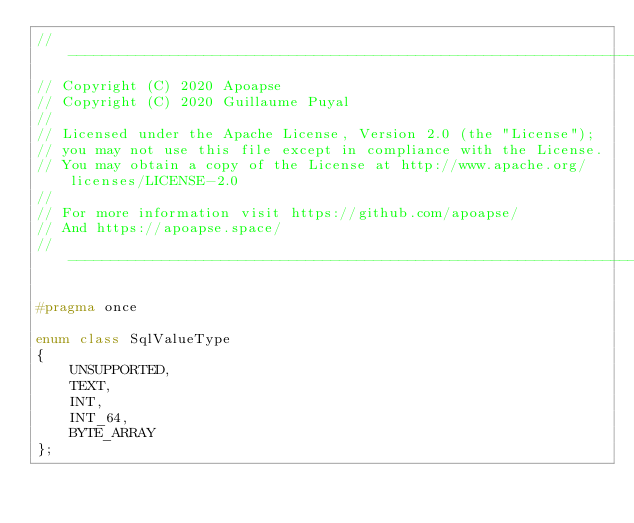<code> <loc_0><loc_0><loc_500><loc_500><_C++_>// ----------------------------------------------------------------------------
// Copyright (C) 2020 Apoapse
// Copyright (C) 2020 Guillaume Puyal
//
// Licensed under the Apache License, Version 2.0 (the "License");
// you may not use this file except in compliance with the License.
// You may obtain a copy of the License at http://www.apache.org/licenses/LICENSE-2.0
//
// For more information visit https://github.com/apoapse/
// And https://apoapse.space/
// ----------------------------------------------------------------------------

#pragma once

enum class SqlValueType
{
	UNSUPPORTED,
	TEXT,
	INT,
	INT_64,
	BYTE_ARRAY
};</code> 